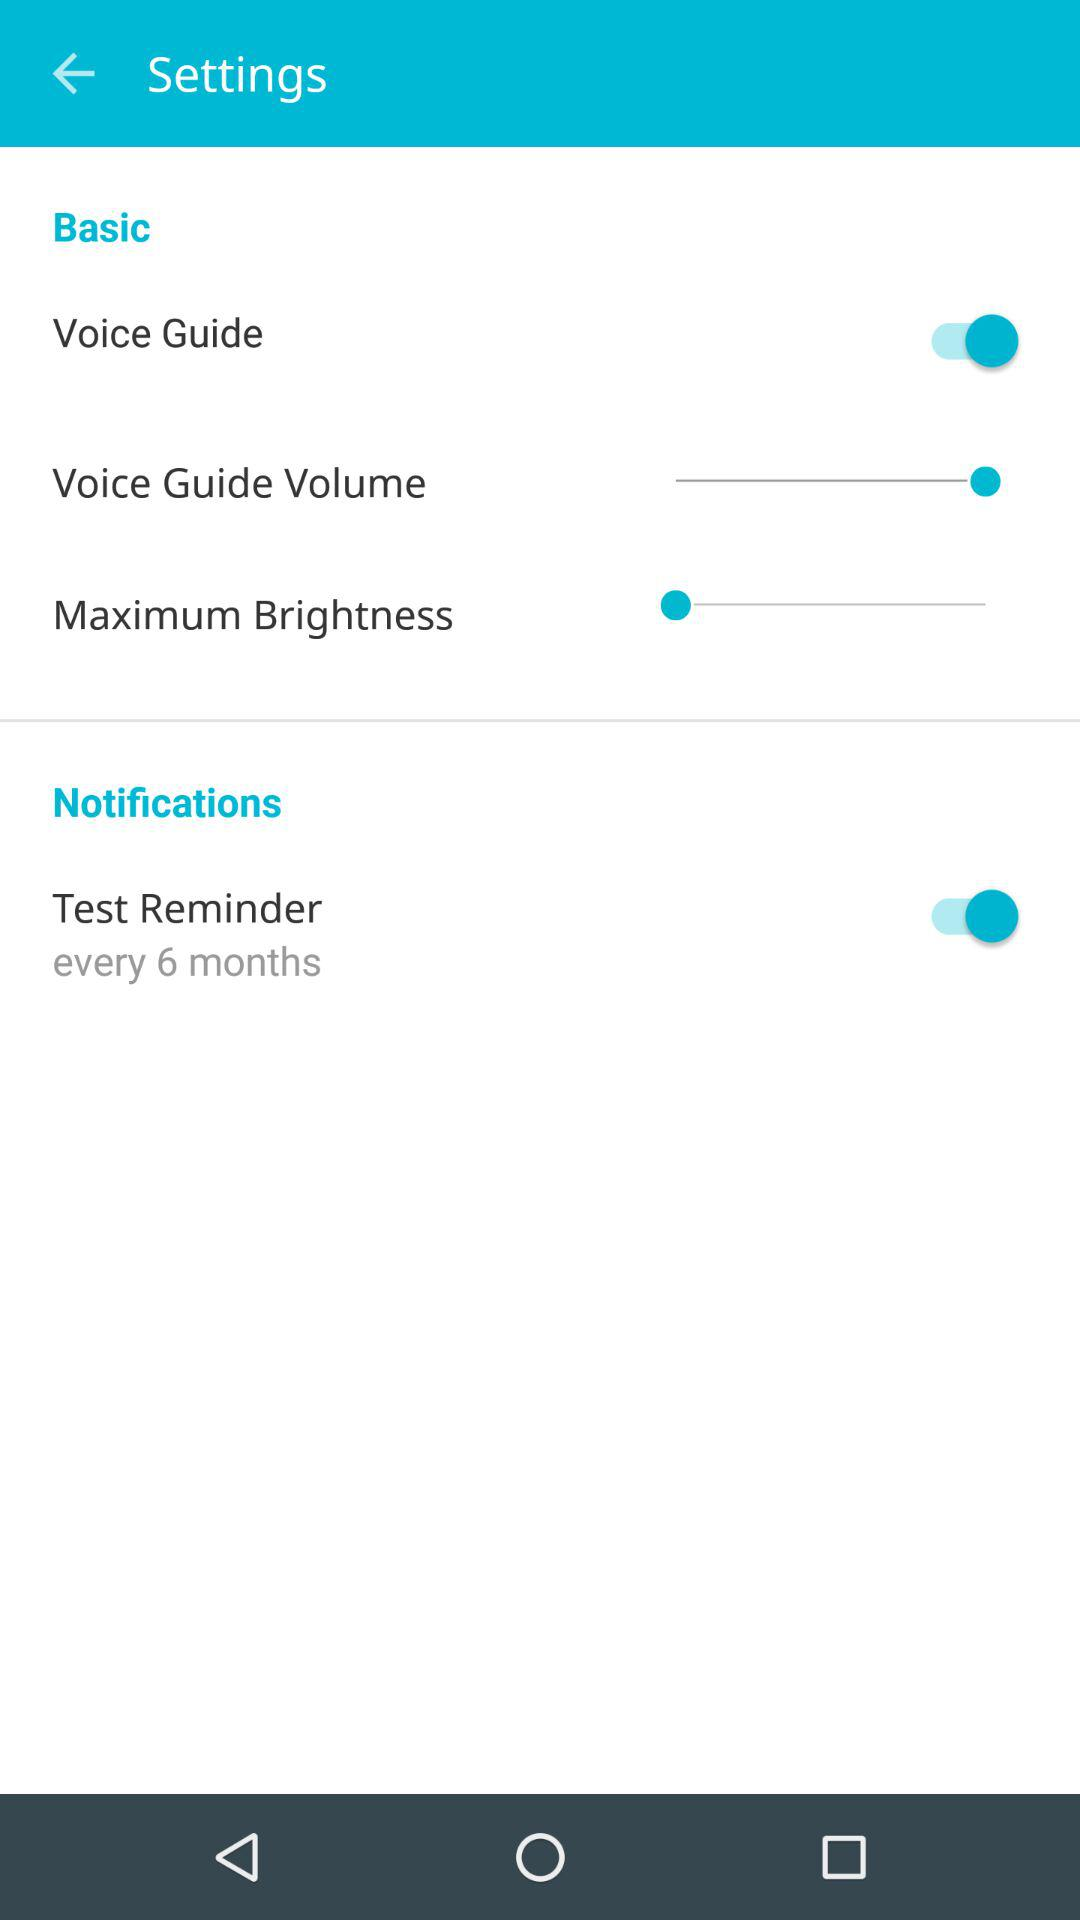What is the setting for "Test Reminder"? The setting is "every 6 months". 